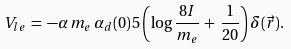<formula> <loc_0><loc_0><loc_500><loc_500>V _ { l e } \, = \, - \alpha \, m _ { e } \, \alpha _ { d } ( 0 ) \, 5 \left ( \log \frac { 8 I } { m _ { e } } \, + \, \frac { 1 } { 2 0 } \right ) \delta ( \vec { r } ) .</formula> 